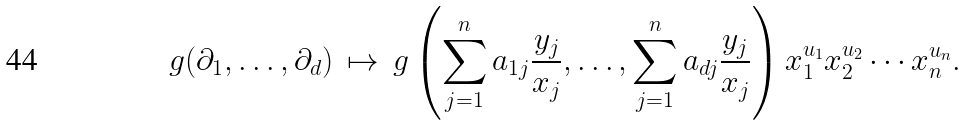<formula> <loc_0><loc_0><loc_500><loc_500>g ( \partial _ { 1 } , \dots , \partial _ { d } ) \, \mapsto \, g \left ( \sum _ { j = 1 } ^ { n } a _ { 1 j } \frac { y _ { j } } { x _ { j } } , \dots , \sum _ { j = 1 } ^ { n } a _ { d j } \frac { y _ { j } } { x _ { j } } \right ) x _ { 1 } ^ { u _ { 1 } } x _ { 2 } ^ { u _ { 2 } } \cdots x _ { n } ^ { u _ { n } } .</formula> 